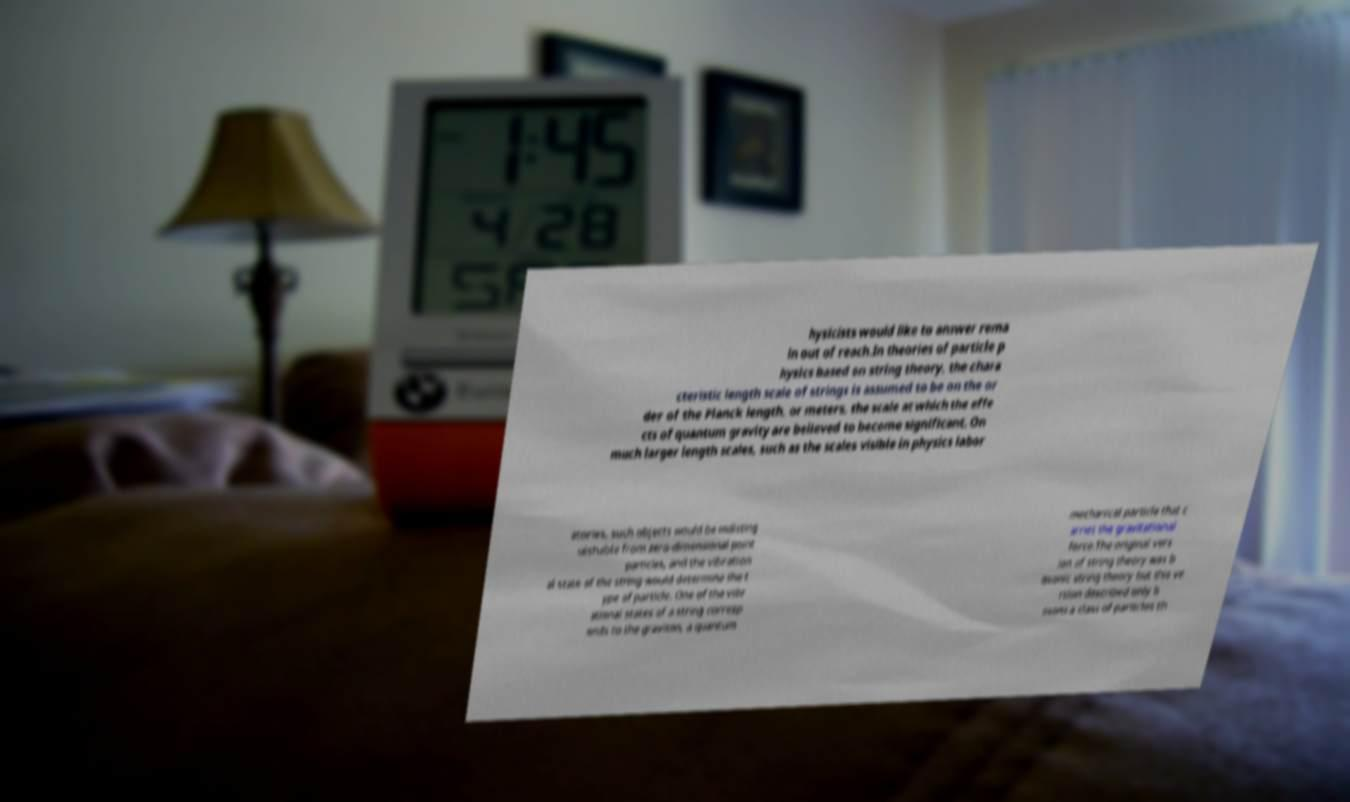Could you extract and type out the text from this image? hysicists would like to answer rema in out of reach.In theories of particle p hysics based on string theory, the chara cteristic length scale of strings is assumed to be on the or der of the Planck length, or meters, the scale at which the effe cts of quantum gravity are believed to become significant. On much larger length scales, such as the scales visible in physics labor atories, such objects would be indisting uishable from zero-dimensional point particles, and the vibration al state of the string would determine the t ype of particle. One of the vibr ational states of a string corresp onds to the graviton, a quantum mechanical particle that c arries the gravitational force.The original vers ion of string theory was b osonic string theory but this ve rsion described only b osons a class of particles th 